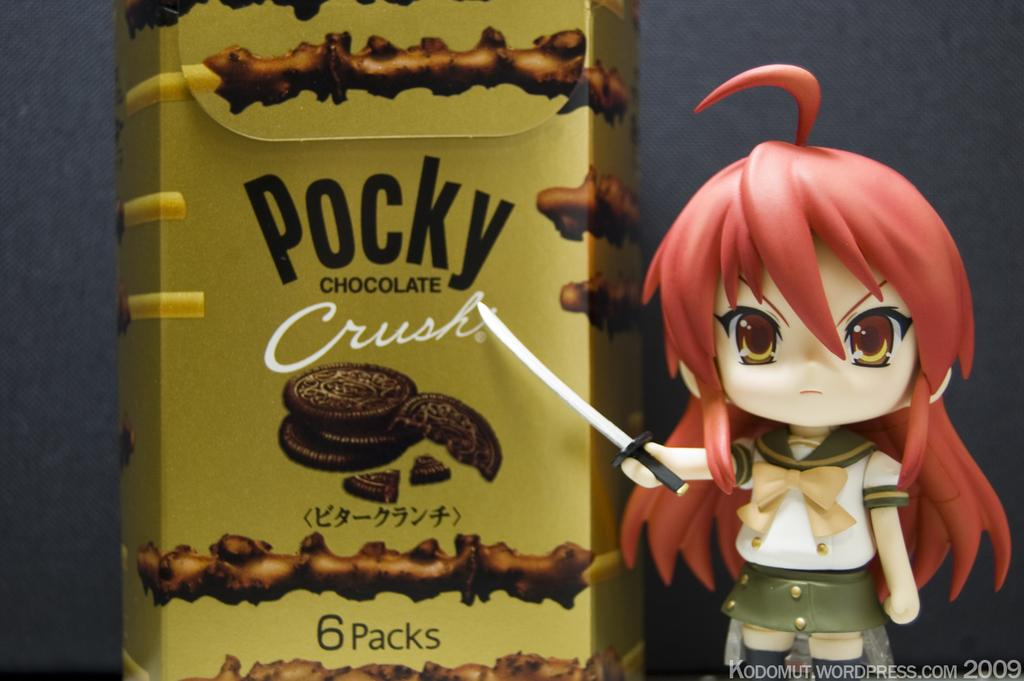What type of image is being described? The image is animated. What can be seen in the animated image? There is a cartoon character in the image. What object is present in the image alongside the cartoon character? There is a chocolate can in the image. What type of honey is being used as a punishment for the cartoon character in the image? There is no honey or punishment present in the image; it features an animated cartoon character and a chocolate can. 